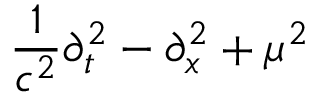<formula> <loc_0><loc_0><loc_500><loc_500>{ \frac { 1 } { c ^ { 2 } } } \partial _ { t } ^ { 2 } - \partial _ { x } ^ { 2 } + \mu ^ { 2 }</formula> 